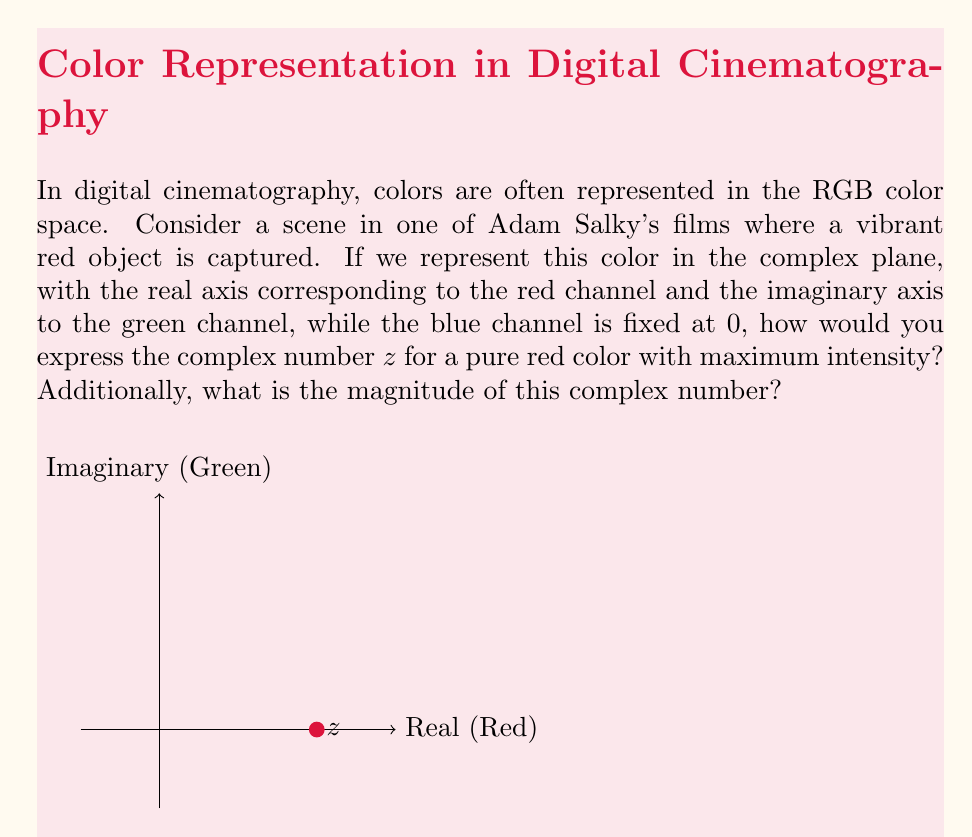Give your solution to this math problem. Let's approach this step-by-step:

1) In the RGB color space, colors are represented by three values: (R, G, B), each ranging from 0 to 255 (or 0 to 1 in normalized form).

2) For a pure, maximum intensity red, we have:
   R = 255 (or 1 in normalized form)
   G = 0
   B = 0

3) In our complex plane representation:
   - The real axis represents the red channel
   - The imaginary axis represents the green channel
   - The blue channel is fixed at 0

4) Therefore, our pure red color can be represented as the complex number:

   $$z = 1 + 0i$$

5) To find the magnitude of this complex number, we use the formula:

   $$|z| = \sqrt{a^2 + b^2}$$

   where $a$ is the real part and $b$ is the imaginary part.

6) Substituting our values:

   $$|z| = \sqrt{1^2 + 0^2} = \sqrt{1} = 1$$

This representation allows filmmakers to analyze and manipulate colors mathematically in post-production, which can be crucial for achieving the desired visual aesthetics in digital cinematography.
Answer: $z = 1 + 0i$, $|z| = 1$ 